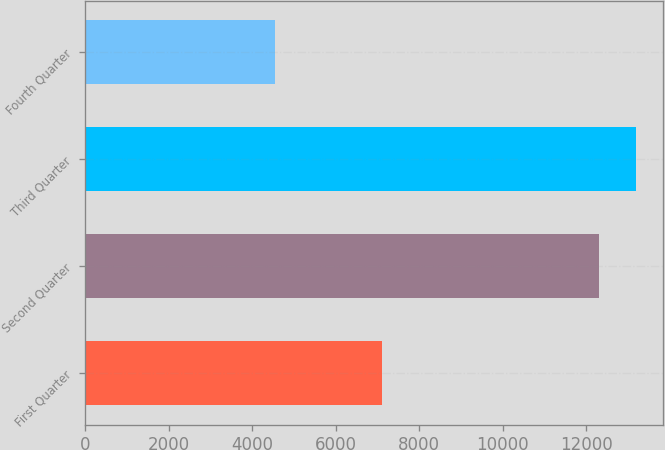Convert chart. <chart><loc_0><loc_0><loc_500><loc_500><bar_chart><fcel>First Quarter<fcel>Second Quarter<fcel>Third Quarter<fcel>Fourth Quarter<nl><fcel>7114<fcel>12319<fcel>13189<fcel>4550<nl></chart> 